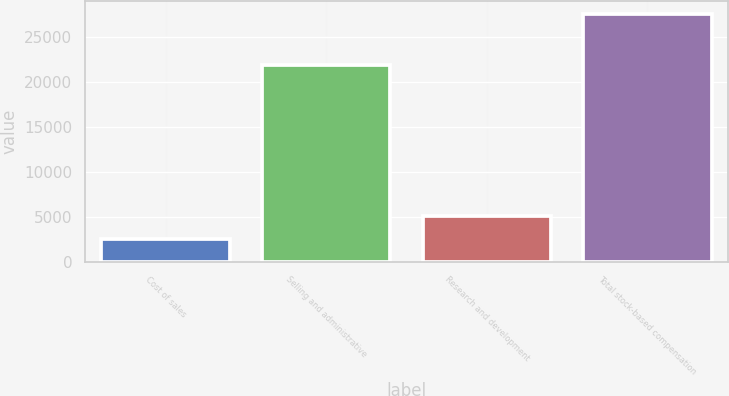<chart> <loc_0><loc_0><loc_500><loc_500><bar_chart><fcel>Cost of sales<fcel>Selling and administrative<fcel>Research and development<fcel>Total stock-based compensation<nl><fcel>2566<fcel>21891<fcel>5067.3<fcel>27579<nl></chart> 